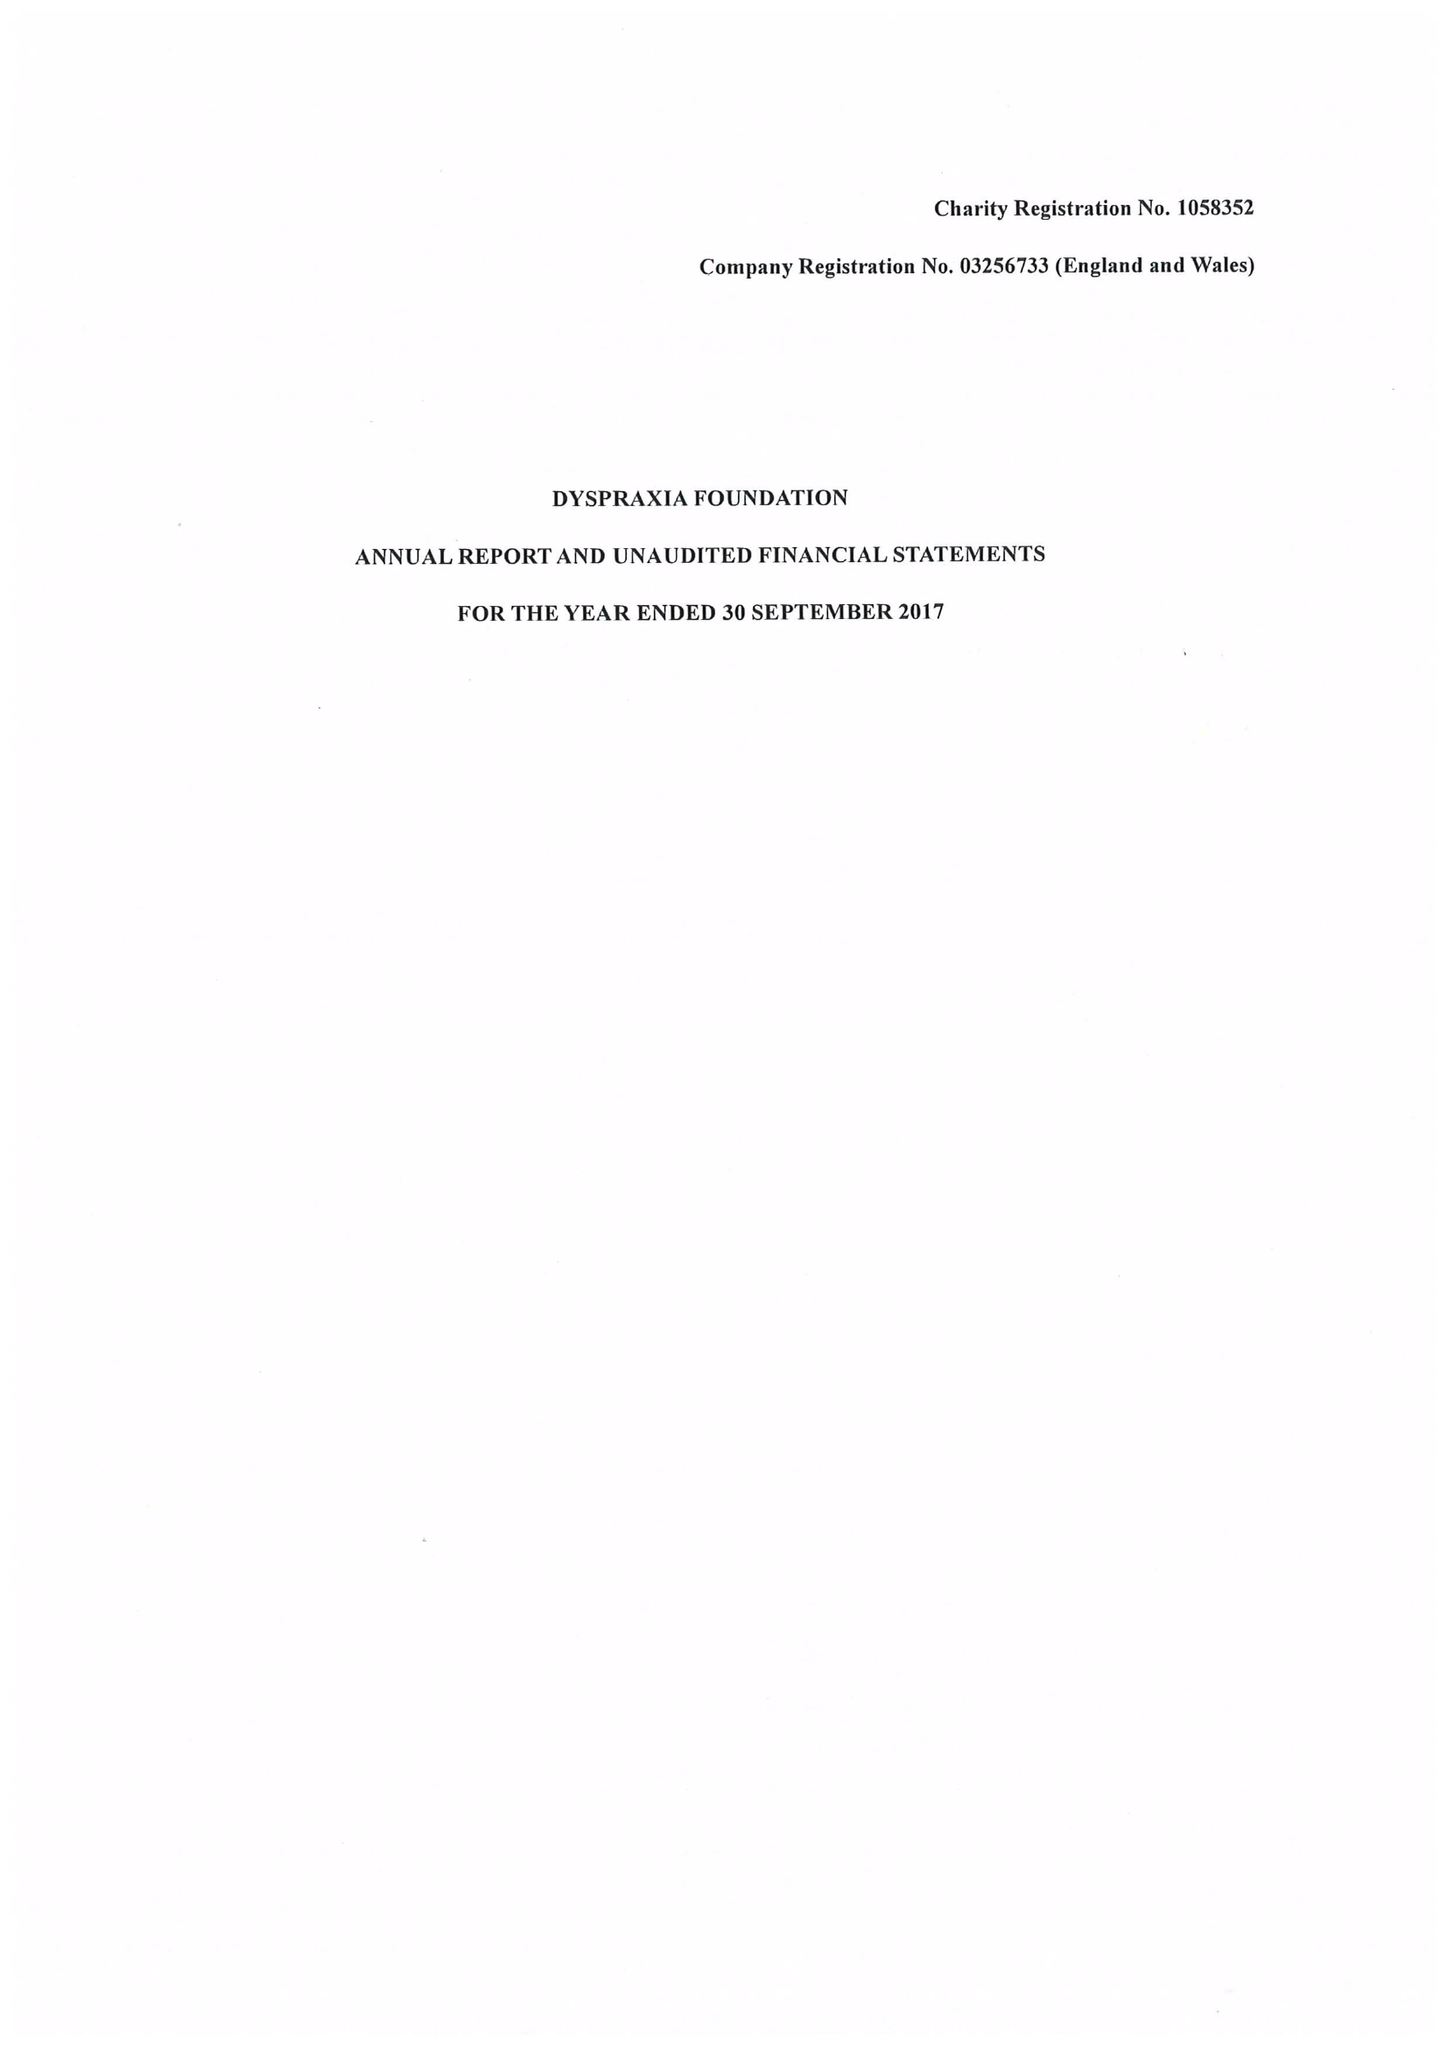What is the value for the address__postcode?
Answer the question using a single word or phrase. SG5 1EG 